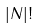<formula> <loc_0><loc_0><loc_500><loc_500>| N | !</formula> 